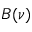Convert formula to latex. <formula><loc_0><loc_0><loc_500><loc_500>B ( \nu )</formula> 